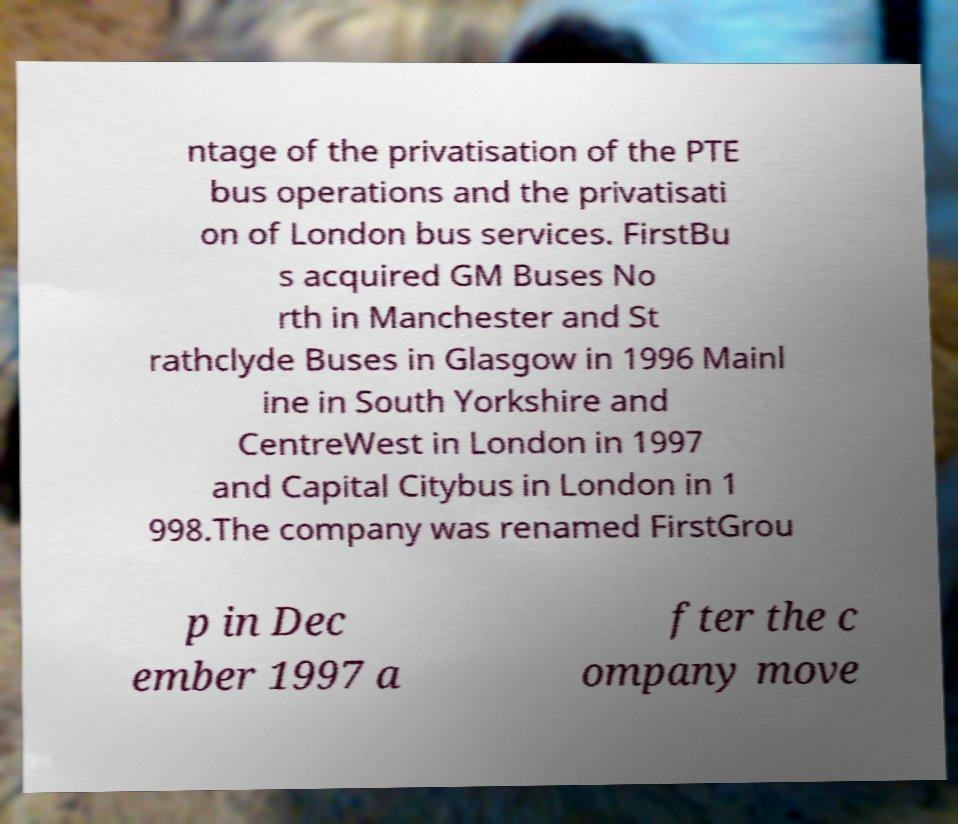What messages or text are displayed in this image? I need them in a readable, typed format. ntage of the privatisation of the PTE bus operations and the privatisati on of London bus services. FirstBu s acquired GM Buses No rth in Manchester and St rathclyde Buses in Glasgow in 1996 Mainl ine in South Yorkshire and CentreWest in London in 1997 and Capital Citybus in London in 1 998.The company was renamed FirstGrou p in Dec ember 1997 a fter the c ompany move 